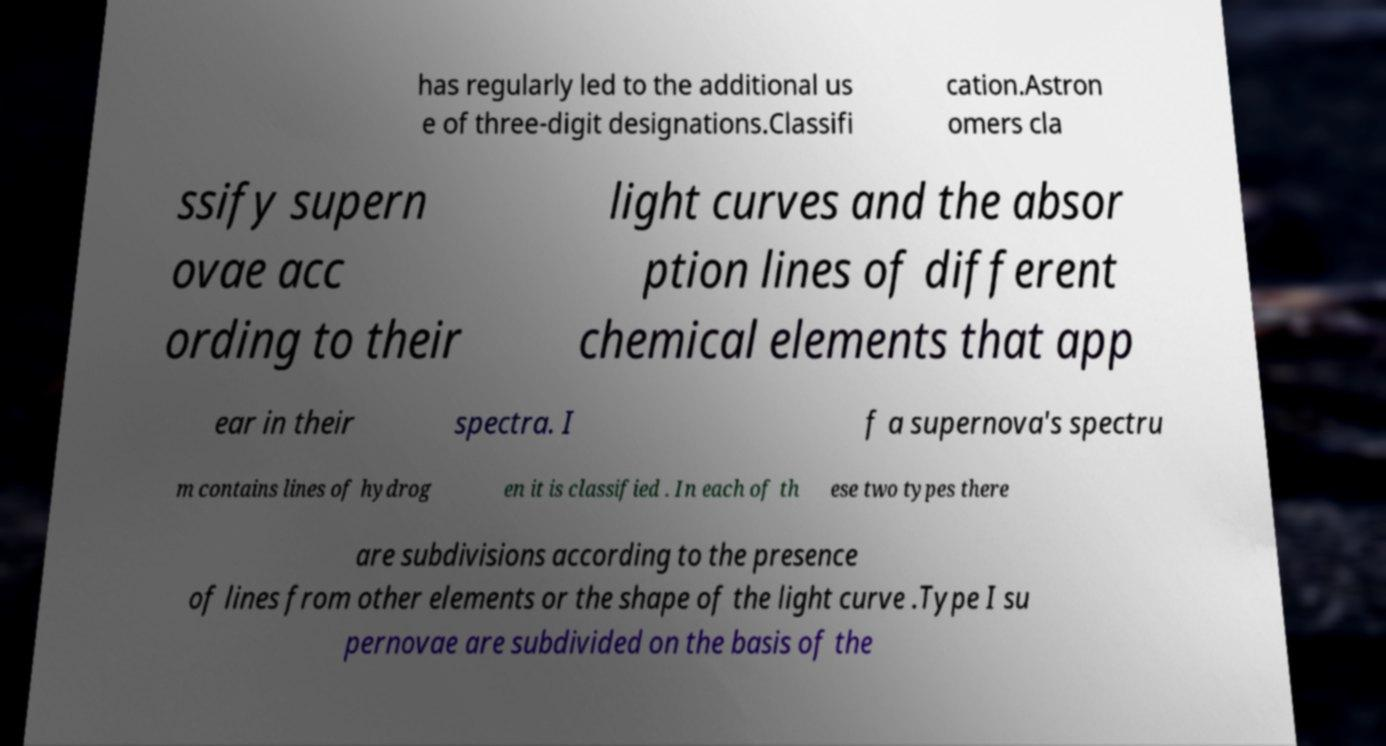There's text embedded in this image that I need extracted. Can you transcribe it verbatim? has regularly led to the additional us e of three-digit designations.Classifi cation.Astron omers cla ssify supern ovae acc ording to their light curves and the absor ption lines of different chemical elements that app ear in their spectra. I f a supernova's spectru m contains lines of hydrog en it is classified . In each of th ese two types there are subdivisions according to the presence of lines from other elements or the shape of the light curve .Type I su pernovae are subdivided on the basis of the 